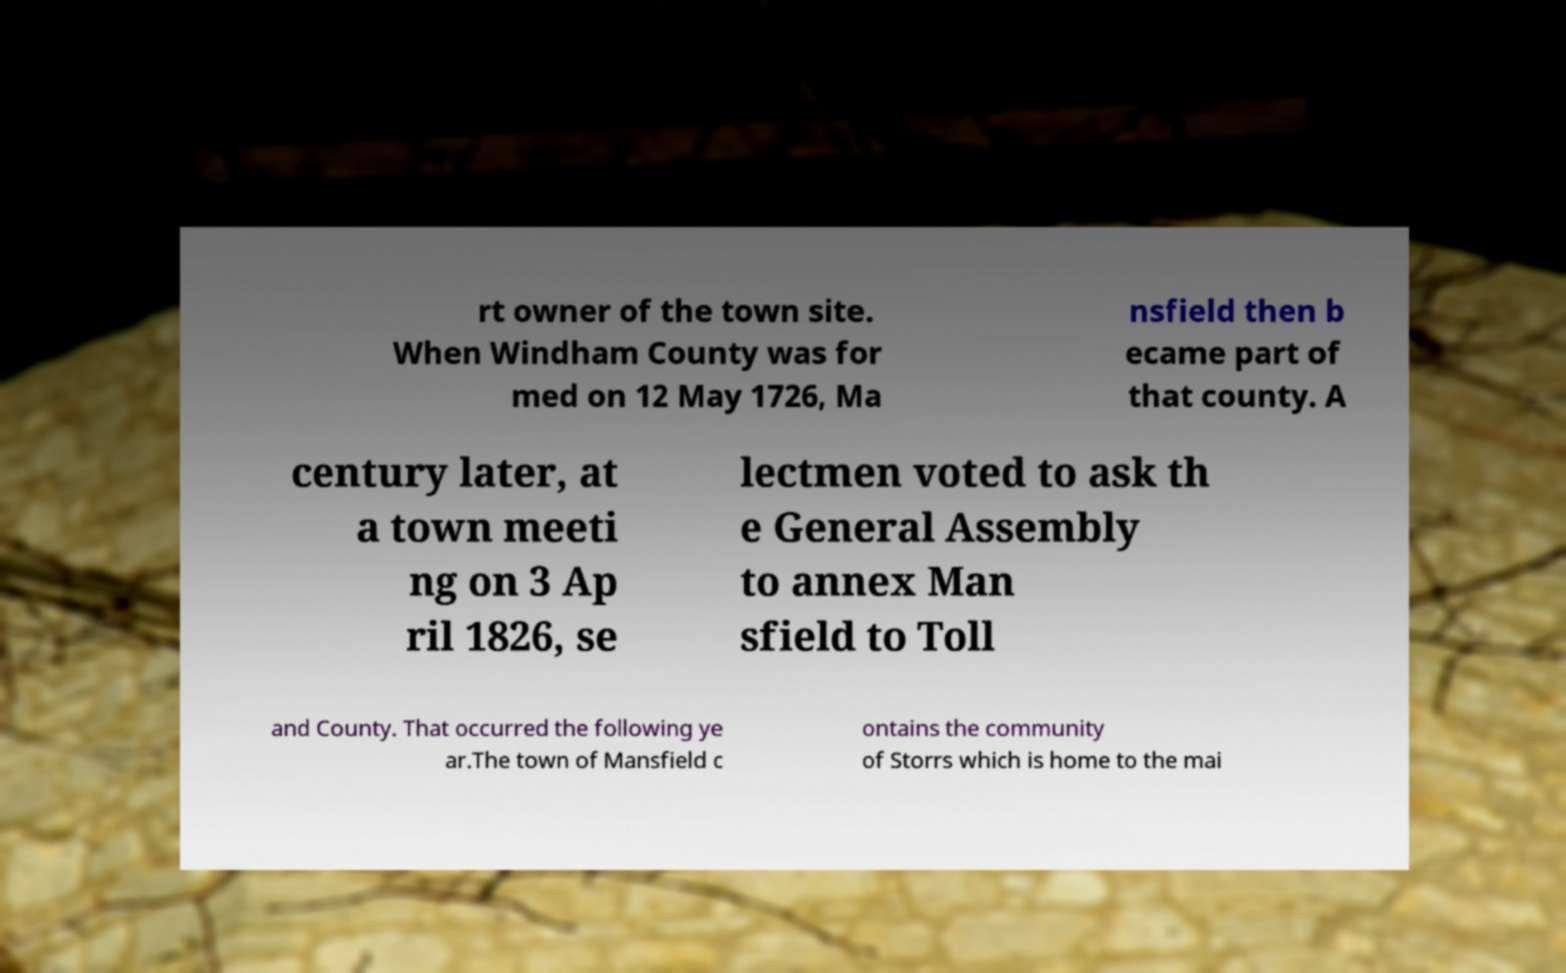Please read and relay the text visible in this image. What does it say? rt owner of the town site. When Windham County was for med on 12 May 1726, Ma nsfield then b ecame part of that county. A century later, at a town meeti ng on 3 Ap ril 1826, se lectmen voted to ask th e General Assembly to annex Man sfield to Toll and County. That occurred the following ye ar.The town of Mansfield c ontains the community of Storrs which is home to the mai 